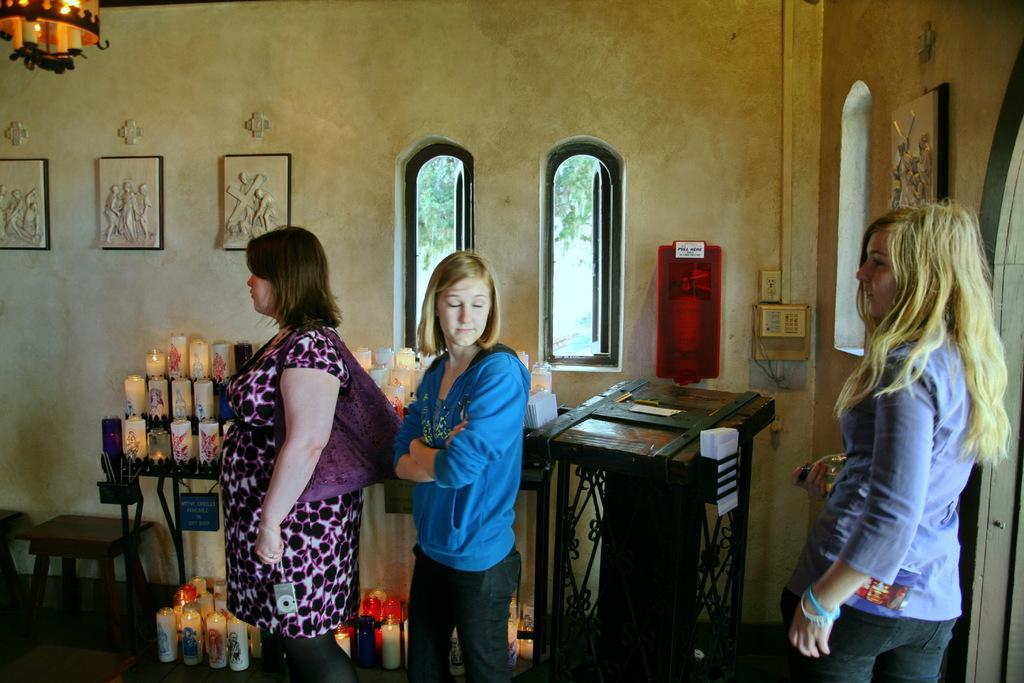Describe this image in one or two sentences. In the picture we can see three women's are standing beside them there is a stool and candle are placed. This is a wall and there are two windows. This is a podium. 